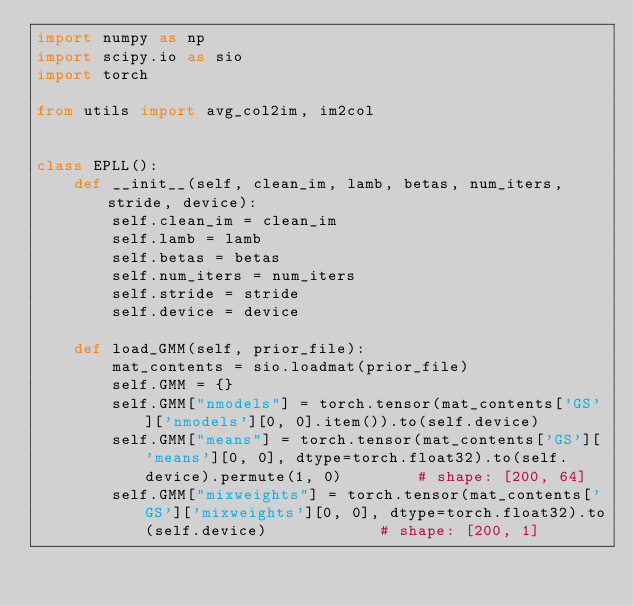<code> <loc_0><loc_0><loc_500><loc_500><_Python_>import numpy as np
import scipy.io as sio
import torch

from utils import avg_col2im, im2col


class EPLL():
    def __init__(self, clean_im, lamb, betas, num_iters, stride, device):
        self.clean_im = clean_im
        self.lamb = lamb
        self.betas = betas
        self.num_iters = num_iters
        self.stride = stride
        self.device = device

    def load_GMM(self, prior_file):
        mat_contents = sio.loadmat(prior_file)
        self.GMM = {}
        self.GMM["nmodels"] = torch.tensor(mat_contents['GS']['nmodels'][0, 0].item()).to(self.device)
        self.GMM["means"] = torch.tensor(mat_contents['GS']['means'][0, 0], dtype=torch.float32).to(self.device).permute(1, 0)        # shape: [200, 64]
        self.GMM["mixweights"] = torch.tensor(mat_contents['GS']['mixweights'][0, 0], dtype=torch.float32).to(self.device)            # shape: [200, 1]</code> 